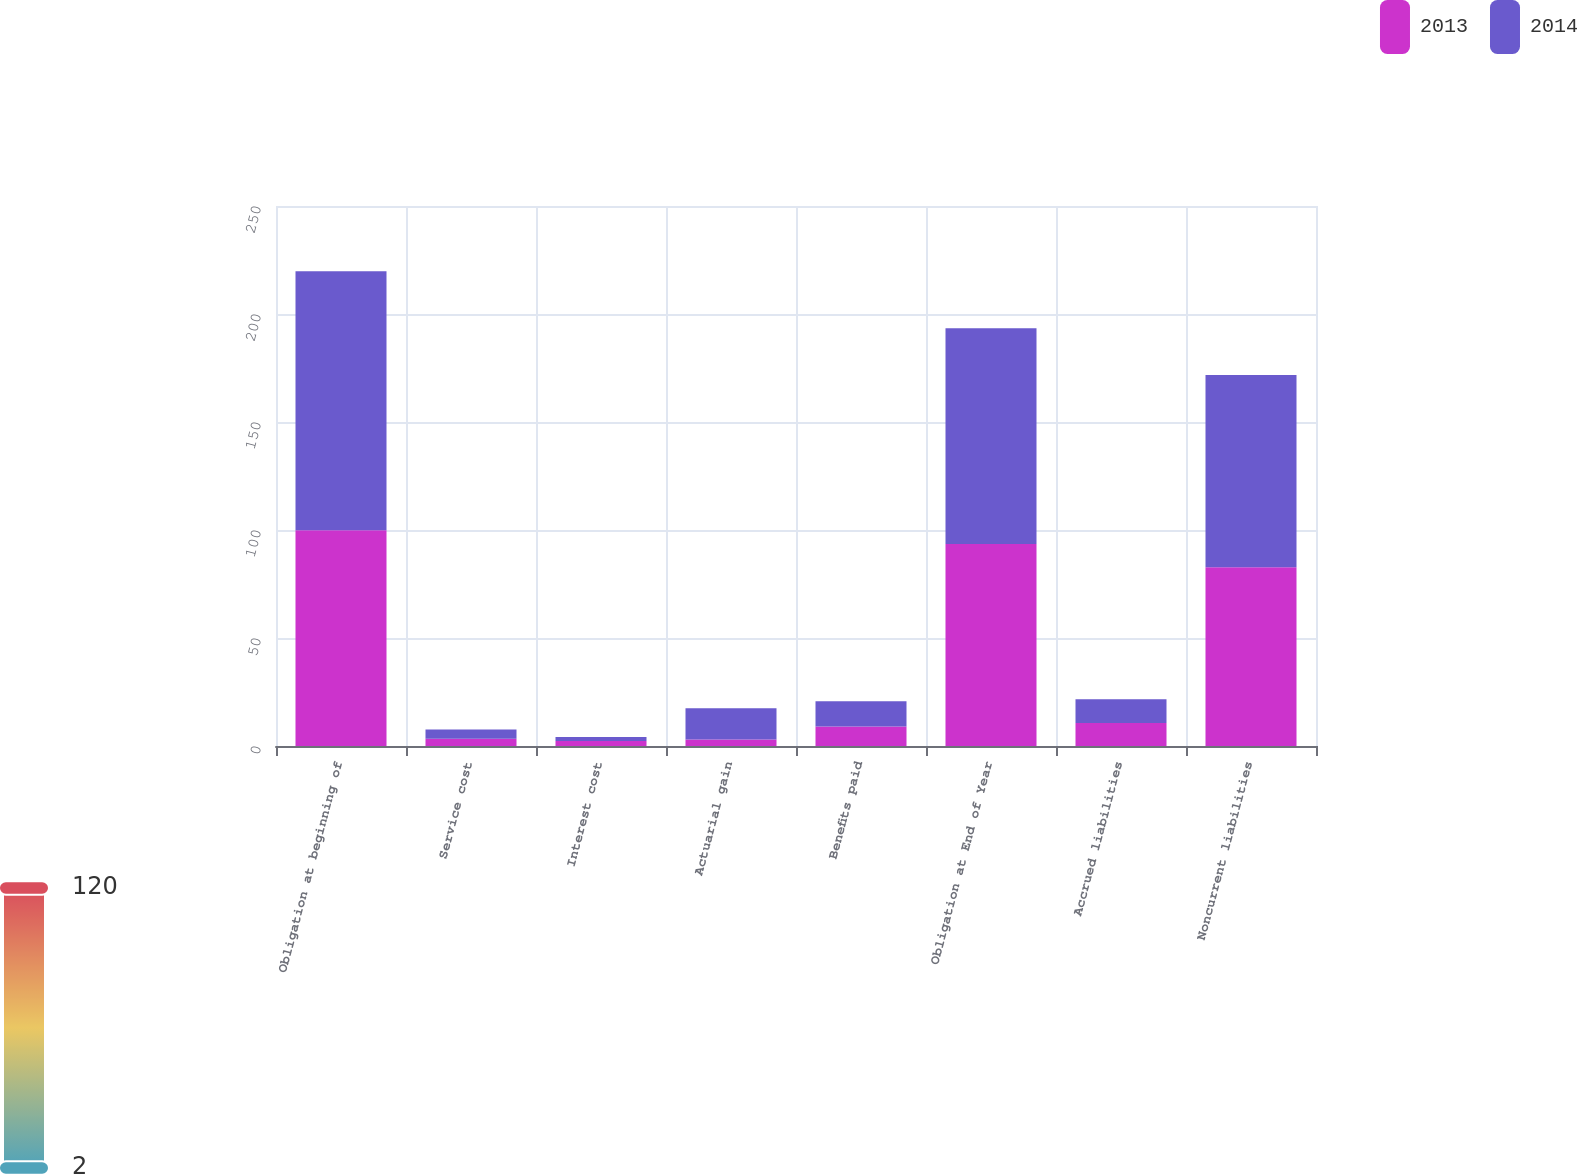<chart> <loc_0><loc_0><loc_500><loc_500><stacked_bar_chart><ecel><fcel>Obligation at beginning of<fcel>Service cost<fcel>Interest cost<fcel>Actuarial gain<fcel>Benefits paid<fcel>Obligation at End of Year<fcel>Accrued liabilities<fcel>Noncurrent liabilities<nl><fcel>2013<fcel>99.9<fcel>3.3<fcel>2.3<fcel>3<fcel>9<fcel>93.5<fcel>10.7<fcel>82.8<nl><fcel>2014<fcel>119.9<fcel>4.3<fcel>1.9<fcel>14.5<fcel>11.7<fcel>99.9<fcel>10.9<fcel>89<nl></chart> 